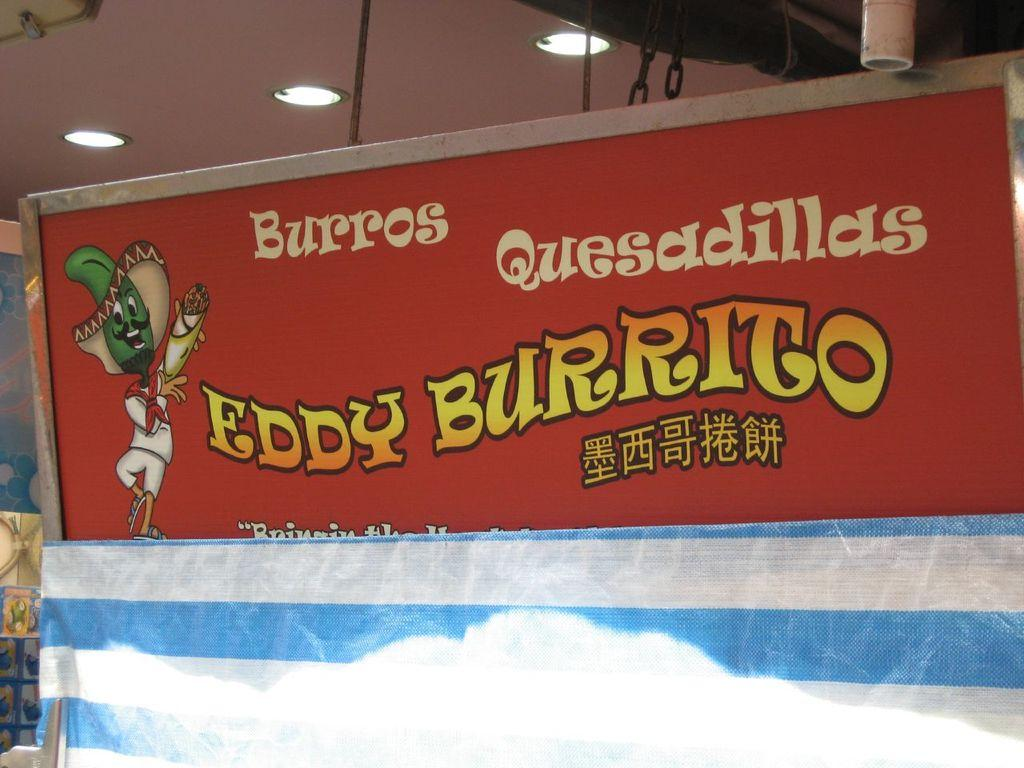<image>
Describe the image concisely. A banner for Burros Quesadillas from Eddy Burrito advertises the product. 